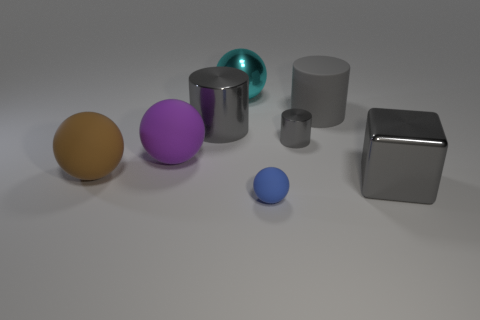How many gray cylinders must be subtracted to get 1 gray cylinders? 2 Subtract all cyan shiny balls. How many balls are left? 3 Subtract all cylinders. How many objects are left? 5 Add 1 small things. How many objects exist? 9 Subtract all blue balls. How many balls are left? 3 Subtract all big brown cylinders. Subtract all big gray blocks. How many objects are left? 7 Add 6 small blue rubber balls. How many small blue rubber balls are left? 7 Add 5 purple objects. How many purple objects exist? 6 Subtract 0 gray balls. How many objects are left? 8 Subtract 2 balls. How many balls are left? 2 